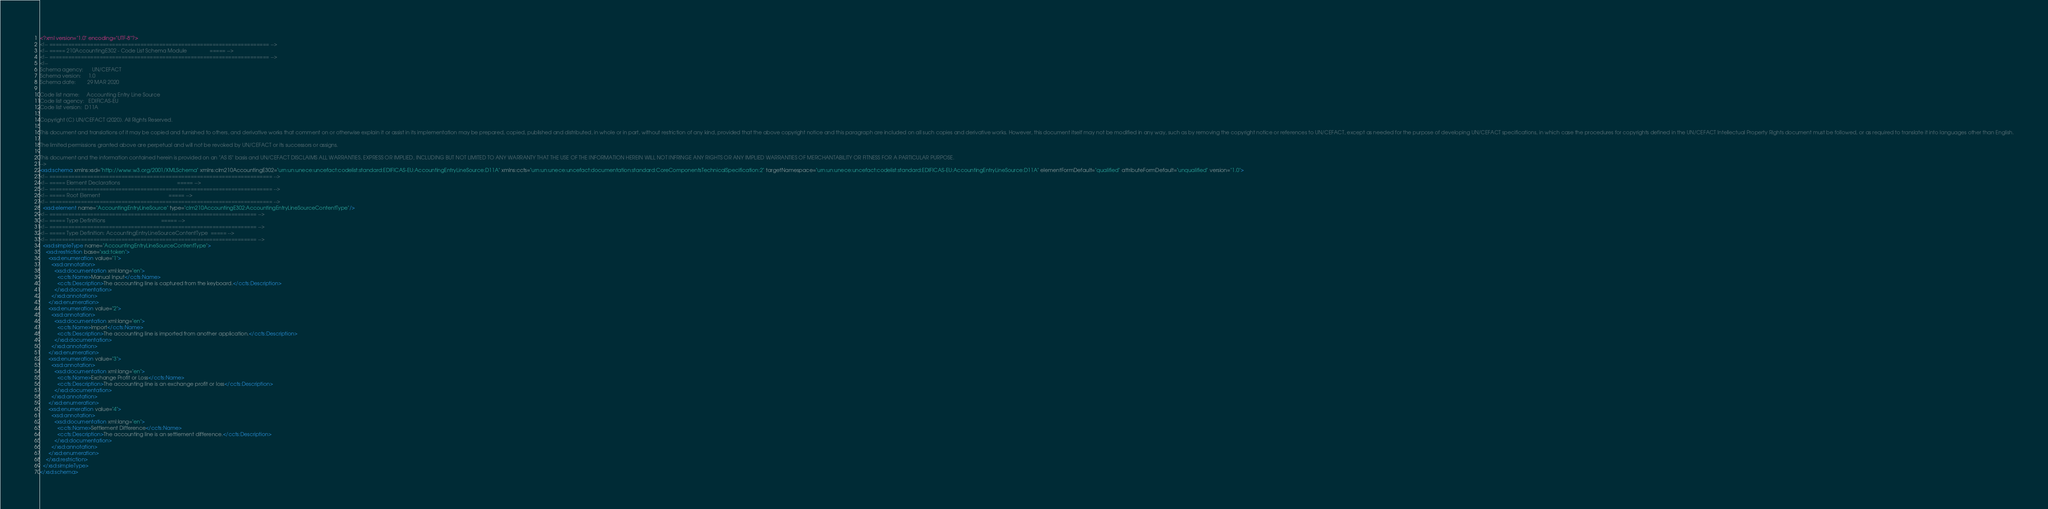<code> <loc_0><loc_0><loc_500><loc_500><_XML_><?xml version="1.0" encoding="UTF-8"?>
<!-- ====================================================================== -->
<!-- ===== 210AccountingE302 - Code List Schema Module                ===== -->
<!-- ====================================================================== -->
<!--
Schema agency:      UN/CEFACT
Schema version:     1.0
Schema date:        29 MAR 2020

Code list name:     Accounting Entry Line Source
Code list agency:   EDIFICAS-EU
Code list version:  D11A

Copyright (C) UN/CEFACT (2020). All Rights Reserved.

This document and translations of it may be copied and furnished to others, and derivative works that comment on or otherwise explain it or assist in its implementation may be prepared, copied, published and distributed, in whole or in part, without restriction of any kind, provided that the above copyright notice and this paragraph are included on all such copies and derivative works. However, this document itself may not be modified in any way, such as by removing the copyright notice or references to UN/CEFACT, except as needed for the purpose of developing UN/CEFACT specifications, in which case the procedures for copyrights defined in the UN/CEFACT Intellectual Property Rights document must be followed, or as required to translate it into languages other than English.

The limited permissions granted above are perpetual and will not be revoked by UN/CEFACT or its successors or assigns.

This document and the information contained herein is provided on an "AS IS" basis and UN/CEFACT DISCLAIMS ALL WARRANTIES, EXPRESS OR IMPLIED, INCLUDING BUT NOT LIMITED TO ANY WARRANTY THAT THE USE OF THE INFORMATION HEREIN WILL NOT INFRINGE ANY RIGHTS OR ANY IMPLIED WARRANTIES OF MERCHANTABILITY OR FITNESS FOR A PARTICULAR PURPOSE.
-->
<xsd:schema xmlns:xsd="http://www.w3.org/2001/XMLSchema" xmlns:clm210AccountingE302="urn:un:unece:uncefact:codelist:standard:EDIFICAS-EU:AccountingEntryLineSource:D11A" xmlns:ccts="urn:un:unece:uncefact:documentation:standard:CoreComponentsTechnicalSpecification:2" targetNamespace="urn:un:unece:uncefact:codelist:standard:EDIFICAS-EU:AccountingEntryLineSource:D11A" elementFormDefault="qualified" attributeFormDefault="unqualified" version="1.0">
<!-- ======================================================================= -->
<!-- ===== Element Declarations                                        ===== -->
<!-- ======================================================================= -->
<!-- ===== Root Element                                                ===== -->
<!-- ======================================================================= -->
  <xsd:element name="AccountingEntryLineSource" type="clm210AccountingE302:AccountingEntryLineSourceContentType"/>
<!-- ================================================================== -->
<!-- ===== Type Definitions                                       ===== -->
<!-- ================================================================== -->
<!-- ===== Type Definition: AccountingEntryLineSourceContentType  ===== -->
<!-- ================================================================== -->
  <xsd:simpleType name="AccountingEntryLineSourceContentType">
    <xsd:restriction base="xsd:token">
      <xsd:enumeration value="1">
        <xsd:annotation>
          <xsd:documentation xml:lang="en">
            <ccts:Name>Manual Input</ccts:Name>
            <ccts:Description>The accounting line is captured from the keyboard.</ccts:Description>
          </xsd:documentation>
        </xsd:annotation>
      </xsd:enumeration>
      <xsd:enumeration value="2">
        <xsd:annotation>
          <xsd:documentation xml:lang="en">
            <ccts:Name>Import</ccts:Name>
            <ccts:Description>The accounting line is imported from another application.</ccts:Description>
          </xsd:documentation>
        </xsd:annotation>
      </xsd:enumeration>
      <xsd:enumeration value="3">
        <xsd:annotation>
          <xsd:documentation xml:lang="en">
            <ccts:Name>Exchange Profit or Loss</ccts:Name>
            <ccts:Description>The accounting line is an exchange profit or loss</ccts:Description>
          </xsd:documentation>
        </xsd:annotation>
      </xsd:enumeration>
      <xsd:enumeration value="4">
        <xsd:annotation>
          <xsd:documentation xml:lang="en">
            <ccts:Name>Settlement Difference</ccts:Name>
            <ccts:Description>The accounting line is an settlement difference.</ccts:Description>
          </xsd:documentation>
        </xsd:annotation>
      </xsd:enumeration>
    </xsd:restriction>
  </xsd:simpleType>
</xsd:schema>
</code> 